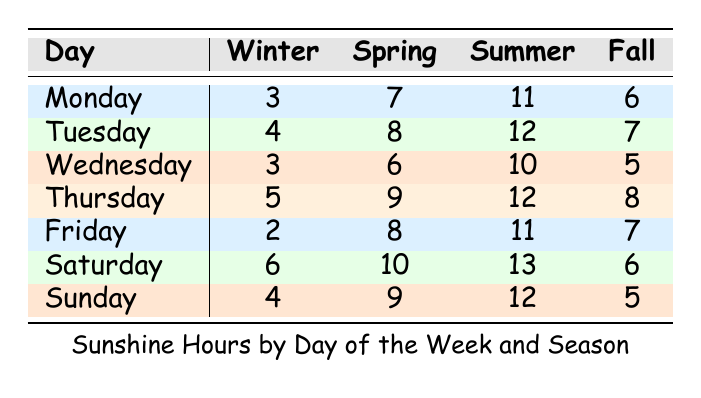What is the Sunshine Hours for Sunday in Spring? According to the table, the entry for Sunday in the Spring season lists the Sunshine Hours as 9.
Answer: 9 Which day has the highest Sunshine Hours in Winter? Looking at the Winter column, Saturday has the highest Sunshine Hours listed as 6.
Answer: Saturday What is the difference in Sunshine Hours between Monday in Summer and Monday in Winter? Monday in Summer has 11 Sunshine Hours, while Monday in Winter has 3. The difference is 11 - 3 = 8.
Answer: 8 Is there more sunshine on Friday in Summer than on Tuesday in Fall? For Friday in Summer, the Sunshine Hours are 11, and for Tuesday in Fall, it's 7. Since 11 is greater than 7, the statement is true.
Answer: Yes What is the average Sunshine Hours for Saturdays across all seasons? Saturdays have Sunshine Hours of 6 (Winter), 10 (Spring), 13 (Summer), and 6 (Fall). The sum is 6 + 10 + 13 + 6 = 35, and there are 4 Saturdays, so the average is 35 / 4 = 8.75.
Answer: 8.75 Which season has the least total Sunshine Hours on Wednesdays? The Sunshine Hours for Wednesday are 3 (Winter), 6 (Spring), 10 (Summer), and 5 (Fall). The total is 3 + 6 + 10 + 5 = 24. Winter has the least Sunshine Hours at 3.
Answer: Winter What is the total Sunshine Hours for all days in Spring? The Sunshine Hours for Spring are 7 (Monday), 8 (Tuesday), 6 (Wednesday), 9 (Thursday), 8 (Friday), 10 (Saturday), and 9 (Sunday). Summing these gives 7 + 8 + 6 + 9 + 8 + 10 + 9 = 57.
Answer: 57 On which day does Summer have the most Sunshine Hours? Looking at the Summer column, Saturday has 13 Sunshine Hours, which is the highest amongst all days.
Answer: Saturday Is it true that Fall has more Sunshine Hours on Thursdays than Winter has on Fridays? For Fall, Thursday has 8 Sunshine Hours, while Winter's Friday lists 2. Since 8 is greater than 2, the statement is true.
Answer: Yes 